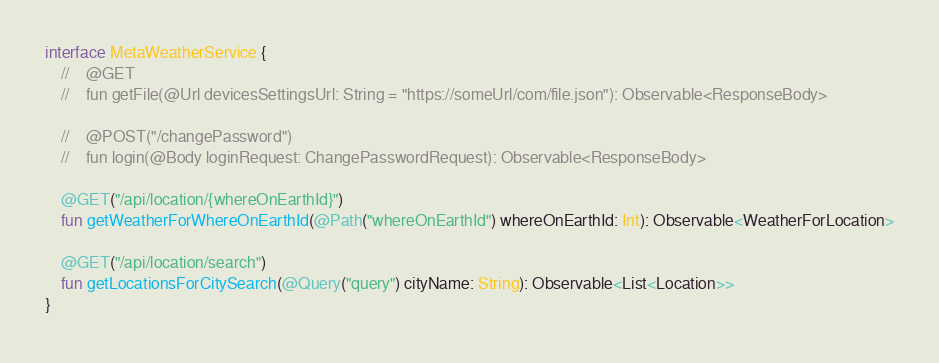<code> <loc_0><loc_0><loc_500><loc_500><_Kotlin_>
interface MetaWeatherService {
    //    @GET
    //    fun getFile(@Url devicesSettingsUrl: String = "https://someUrl/com/file.json"): Observable<ResponseBody>

    //    @POST("/changePassword")
    //    fun login(@Body loginRequest: ChangePasswordRequest): Observable<ResponseBody>

    @GET("/api/location/{whereOnEarthId}")
    fun getWeatherForWhereOnEarthId(@Path("whereOnEarthId") whereOnEarthId: Int): Observable<WeatherForLocation>

    @GET("/api/location/search")
    fun getLocationsForCitySearch(@Query("query") cityName: String): Observable<List<Location>>
}
</code> 